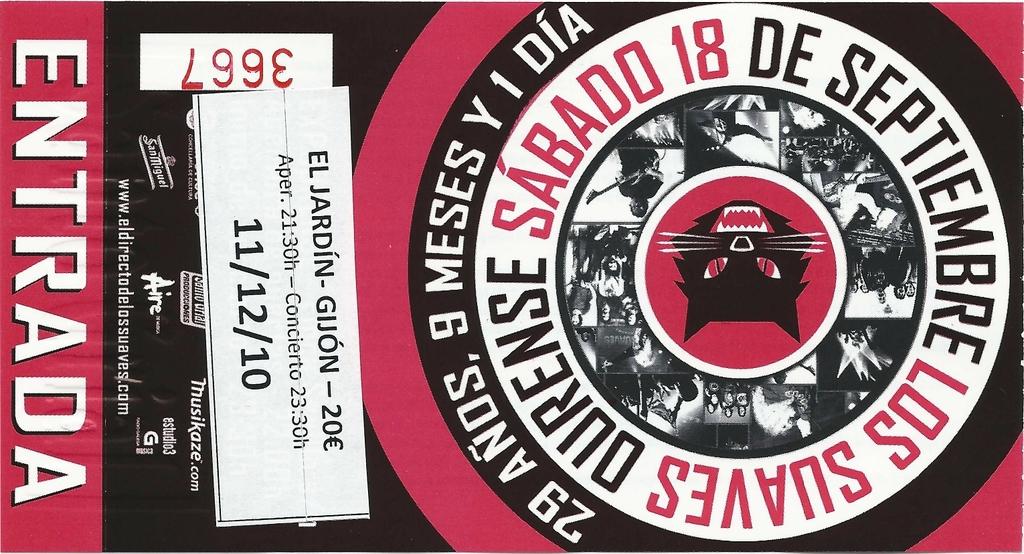How much is entrance fee?
Offer a very short reply. 20 euros. 